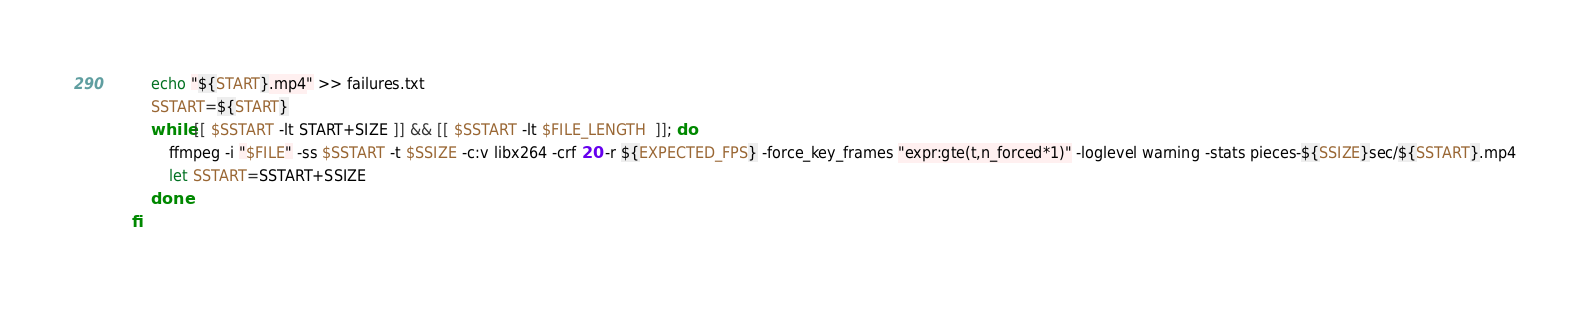Convert code to text. <code><loc_0><loc_0><loc_500><loc_500><_Bash_>        echo "${START}.mp4" >> failures.txt
        SSTART=${START}
        while [[ $SSTART -lt START+SIZE ]] && [[ $SSTART -lt $FILE_LENGTH  ]]; do
            ffmpeg -i "$FILE" -ss $SSTART -t $SSIZE -c:v libx264 -crf 20 -r ${EXPECTED_FPS} -force_key_frames "expr:gte(t,n_forced*1)" -loglevel warning -stats pieces-${SSIZE}sec/${SSTART}.mp4
            let SSTART=SSTART+SSIZE
        done
    fi</code> 